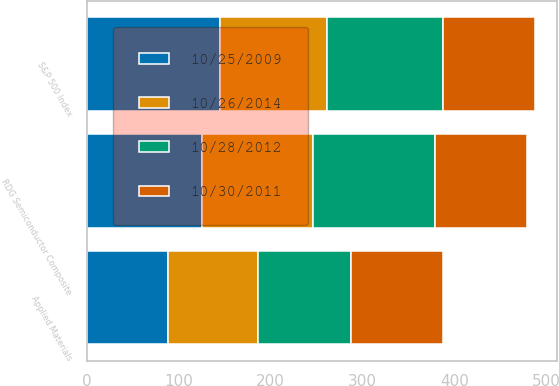Convert chart. <chart><loc_0><loc_0><loc_500><loc_500><stacked_bar_chart><ecel><fcel>Applied Materials<fcel>S&P 500 Index<fcel>RDG Semiconductor Composite<nl><fcel>10/30/2011<fcel>100<fcel>100<fcel>100<nl><fcel>10/26/2014<fcel>97.43<fcel>116.52<fcel>121<nl><fcel>10/28/2012<fcel>101.85<fcel>125.94<fcel>132.42<nl><fcel>10/25/2009<fcel>88.54<fcel>145.09<fcel>124.95<nl></chart> 